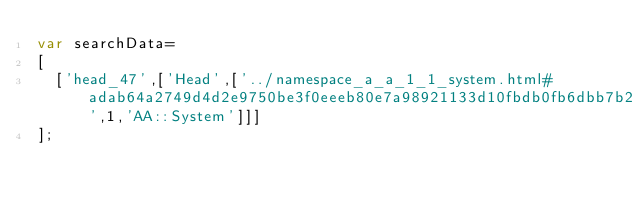Convert code to text. <code><loc_0><loc_0><loc_500><loc_500><_JavaScript_>var searchData=
[
  ['head_47',['Head',['../namespace_a_a_1_1_system.html#adab64a2749d4d2e9750be3f0eeeb80e7a98921133d10fbdb0fb6dbb7b2648befe',1,'AA::System']]]
];
</code> 